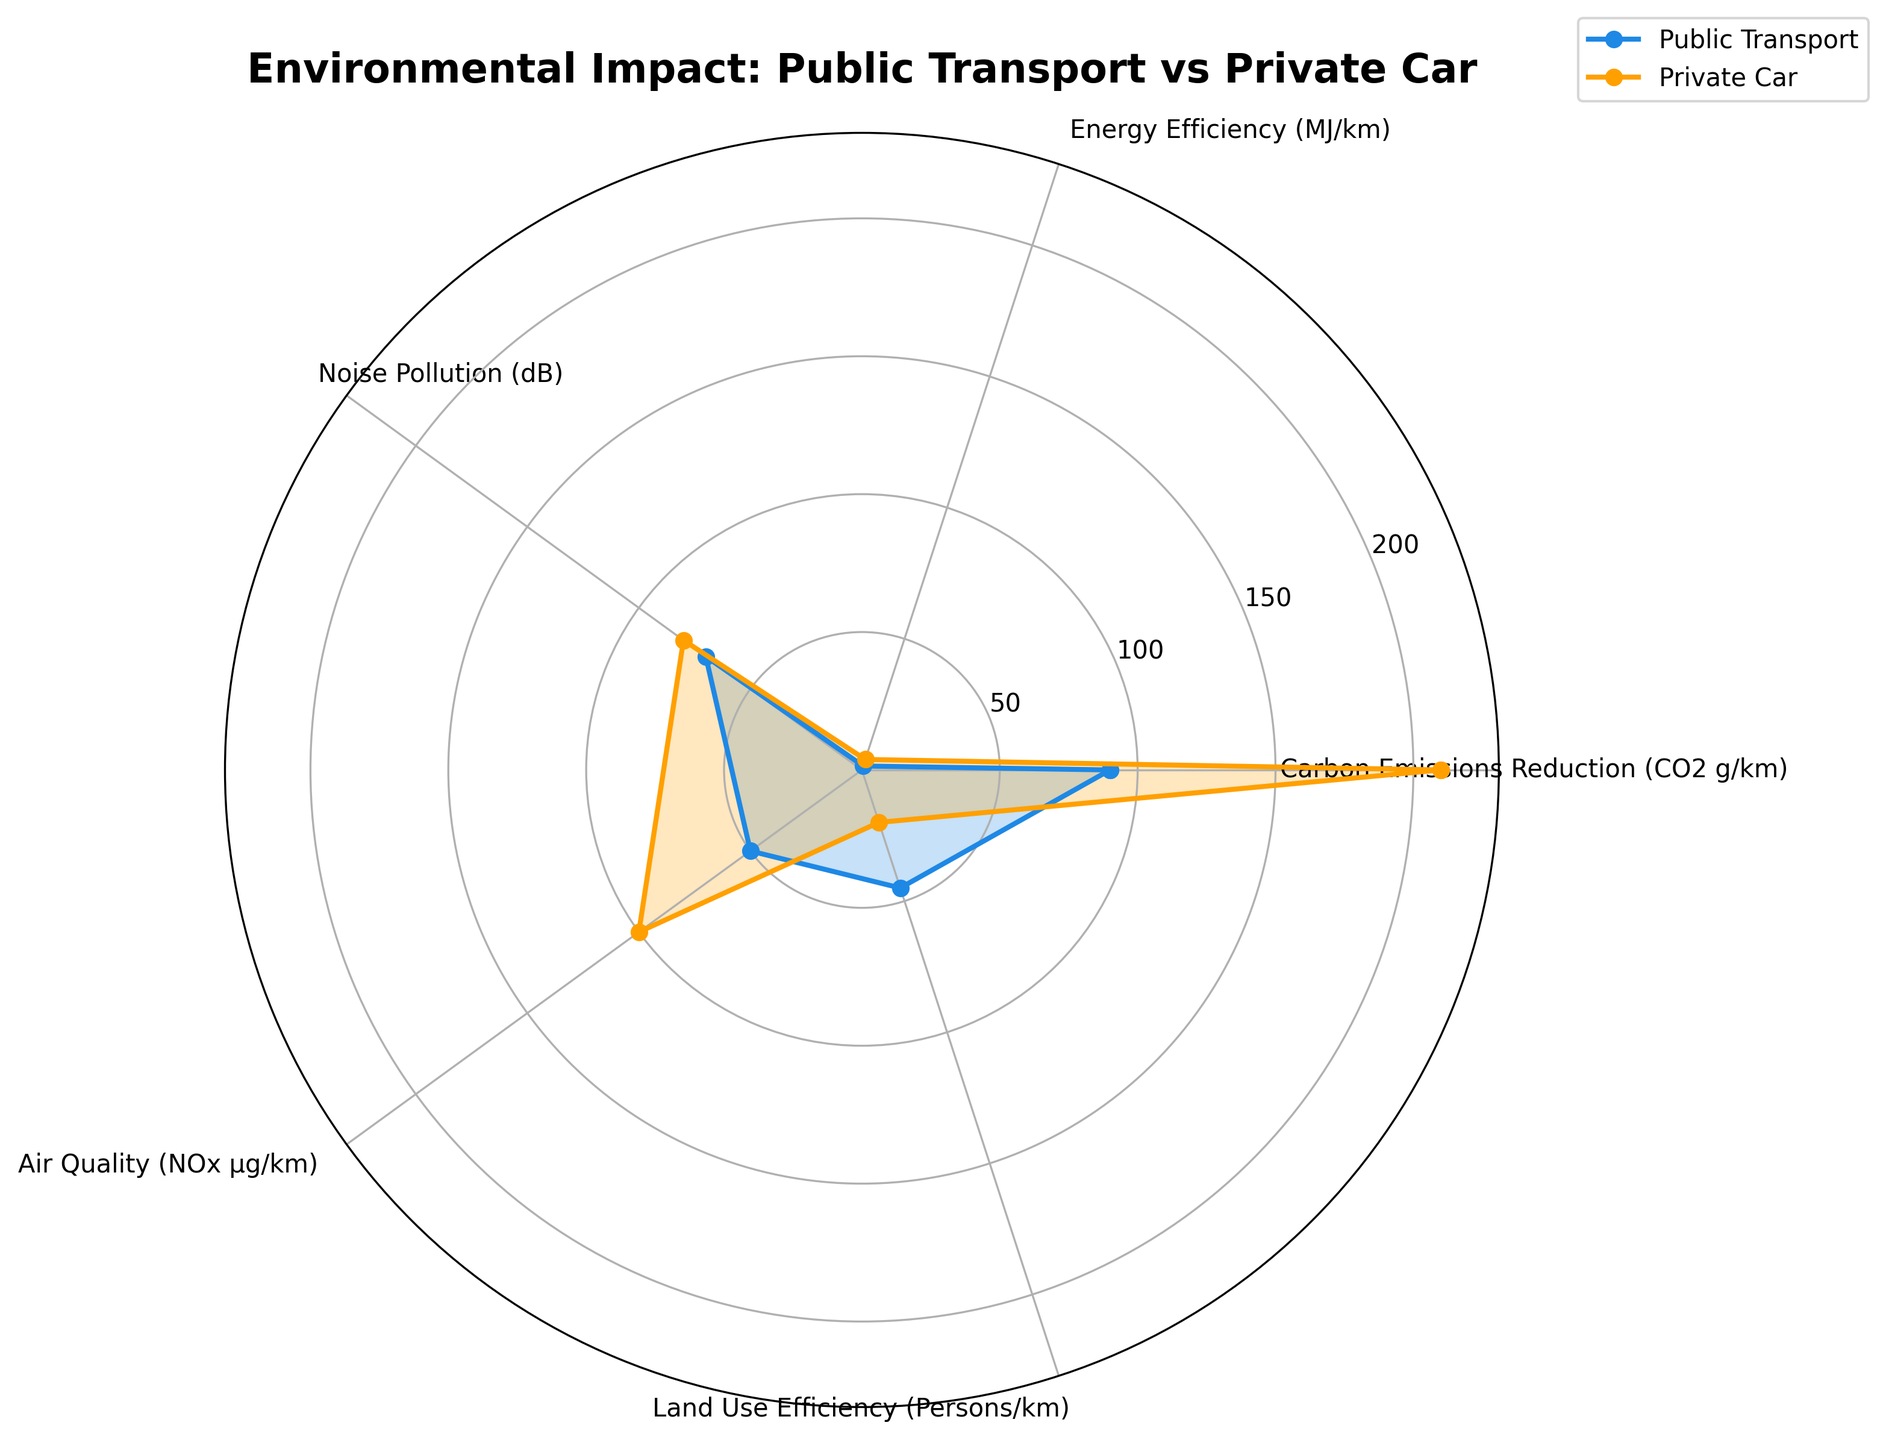What is the title of the radar chart? The title is located at the top of the radar chart. It is often the largest and boldest text on the chart.
Answer: Environmental Impact: Public Transport vs Private Car What categories are shown on the radar chart? The categories are labeled along the perimeter of the radar chart and represent different aspects of environmental impact. They include Carbon Emissions Reduction, Energy Efficiency, Noise Pollution, Air Quality, and Land Use Efficiency.
Answer: Carbon Emissions Reduction, Energy Efficiency, Noise Pollution, Air Quality, Land Use Efficiency Which mode of transport has lower Carbon Emissions Reduction? By examining the plotted lines, the category label corresponding to Carbon Emissions Reduction shows a lower value for Public Transport compared to Private Car.
Answer: Public Transport How does the Energy Efficiency of Public Transport compare to Private Car? By comparing the points on the Energy Efficiency axis, it is clear that the value for Public Transport is much lower than that for Private Car, indicating better energy efficiency.
Answer: Public Transport is more energy-efficient What is the difference in Air Quality (NOx µg/km) between Public Transport and Private Car? To find the difference, subtract the value of Public Transport from Private Car for Air Quality (100 - 50).
Answer: 50 Which mode of transport contributes less to Noise Pollution? Look at the points on the Noise Pollution axis, the value for Public Transport is lower than that for Private Car.
Answer: Public Transport In which category does Public Transport show the highest relative improvement over Private Car? Examine the categories where the difference between Public Transport and Private Car is the largest. In Land Use Efficiency, Public Transport significantly outperforms Private Car (45 vs. 20).
Answer: Land Use Efficiency By how much does Public Transport reduce Carbon Emissions compared to Private Car? Subtract the Carbon Emissions value of Public Transport from that of Private Car (210 - 90).
Answer: 120 What is the average value for Private Car across all categories? Sum the values for Private Car (210 + 4 + 80 + 100 + 20) and divide by the number of categories (5). (414/5)
Answer: 82.8 How do Public Transport and Private Car compare in terms of Land Use Efficiency? Compare the numeric values shown on the Land Use Efficiency axis for both types of transport. Public Transport (45 persons/km) is more efficient than Private Car (20 persons/km).
Answer: Public Transport is more efficient 